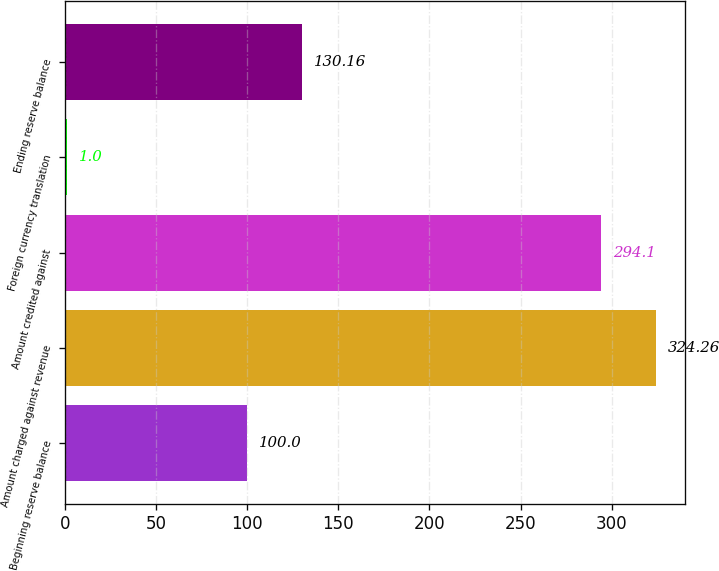Convert chart to OTSL. <chart><loc_0><loc_0><loc_500><loc_500><bar_chart><fcel>Beginning reserve balance<fcel>Amount charged against revenue<fcel>Amount credited against<fcel>Foreign currency translation<fcel>Ending reserve balance<nl><fcel>100<fcel>324.26<fcel>294.1<fcel>1<fcel>130.16<nl></chart> 